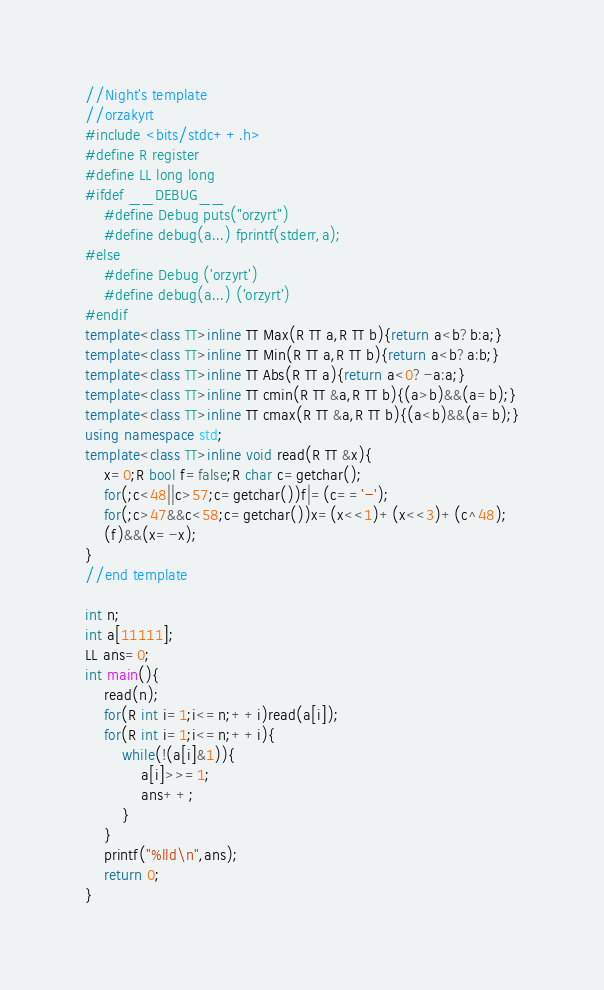<code> <loc_0><loc_0><loc_500><loc_500><_C++_>//Night's template
//orzakyrt
#include <bits/stdc++.h>
#define R register
#define LL long long
#ifdef __DEBUG__
	#define Debug puts("orzyrt")
	#define debug(a...) fprintf(stderr,a);
#else
	#define Debug ('orzyrt')
	#define debug(a...) ('orzyrt')
#endif
template<class TT>inline TT Max(R TT a,R TT b){return a<b?b:a;}
template<class TT>inline TT Min(R TT a,R TT b){return a<b?a:b;}
template<class TT>inline TT Abs(R TT a){return a<0?-a:a;}
template<class TT>inline TT cmin(R TT &a,R TT b){(a>b)&&(a=b);}
template<class TT>inline TT cmax(R TT &a,R TT b){(a<b)&&(a=b);}
using namespace std;
template<class TT>inline void read(R TT &x){
	x=0;R bool f=false;R char c=getchar();
	for(;c<48||c>57;c=getchar())f|=(c=='-');
	for(;c>47&&c<58;c=getchar())x=(x<<1)+(x<<3)+(c^48);
	(f)&&(x=-x);
}
//end template

int n;
int a[11111];
LL ans=0;
int main(){
	read(n);
	for(R int i=1;i<=n;++i)read(a[i]);
	for(R int i=1;i<=n;++i){
		while(!(a[i]&1)){
			a[i]>>=1;
			ans++;
		}
	}
	printf("%lld\n",ans);
	return 0;
}
</code> 